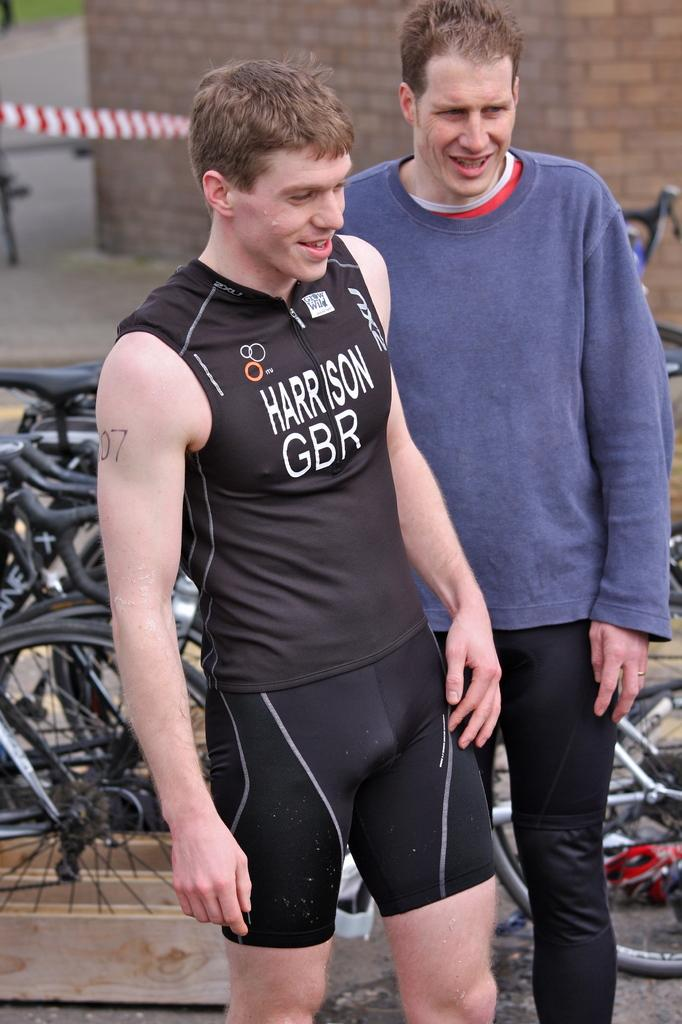Provide a one-sentence caption for the provided image. A male marathoner representing Great Britain is standing with another man in front of bicycles. 